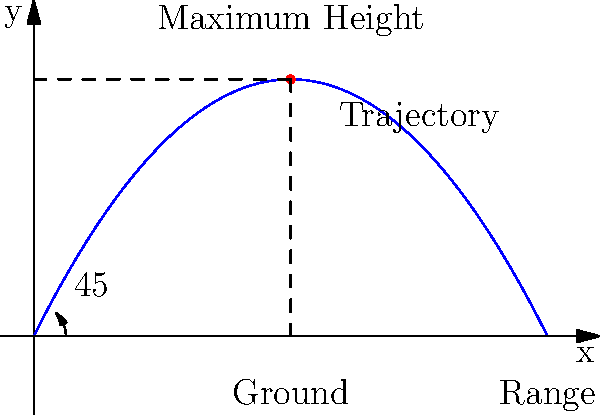In your steampunk-inspired alternate history, you've designed a steam-powered catapult for launching airships. Assuming ideal conditions and neglecting air resistance, what angle should the catapult be set to achieve maximum range? Use the parabolic trajectory illustrated in the diagram to support your answer. To determine the optimal angle for maximum range in a projectile motion, we can follow these steps:

1. Recall that the range of a projectile is given by the formula:
   $$R = \frac{v^2 \sin(2\theta)}{g}$$
   Where $R$ is the range, $v$ is the initial velocity, $\theta$ is the launch angle, and $g$ is the acceleration due to gravity.

2. To maximize the range, we need to maximize $\sin(2\theta)$.

3. The maximum value of sine occurs at 90°, so we want:
   $$2\theta = 90°$$

4. Solving for $\theta$:
   $$\theta = 45°$$

5. This result is illustrated in the diagram, where the parabolic trajectory reaches its maximum range when launched at a 45° angle.

6. The symmetry of the parabola also supports this conclusion: the projectile spends equal time ascending and descending, which occurs when launched at 45°.

In the context of our steampunk alternate history, this principle would apply to steam-powered catapults just as it does to conventional projectiles, assuming ideal conditions.
Answer: 45° 